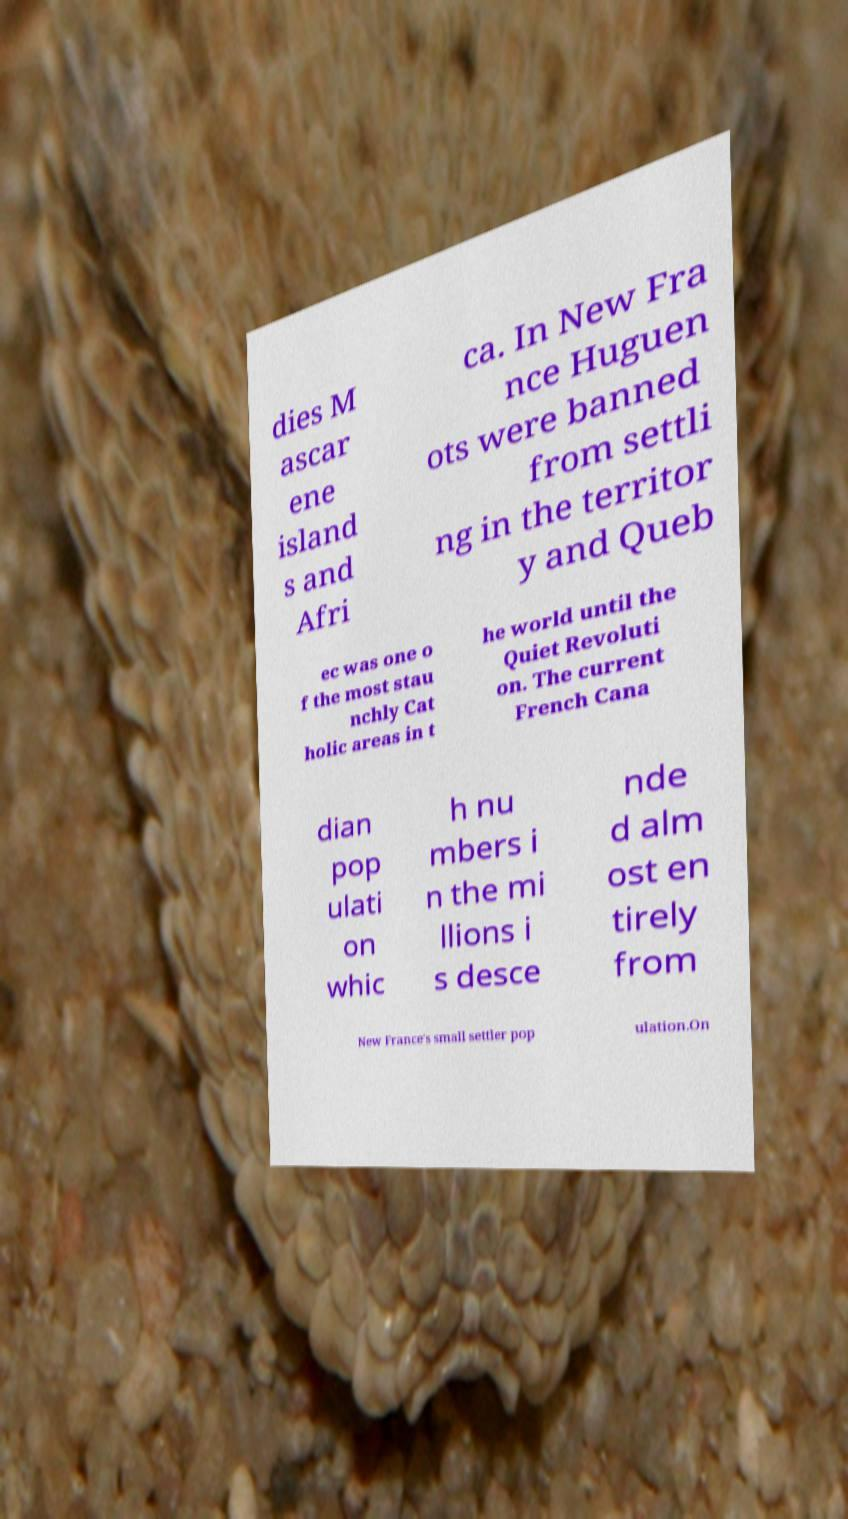Please identify and transcribe the text found in this image. dies M ascar ene island s and Afri ca. In New Fra nce Huguen ots were banned from settli ng in the territor y and Queb ec was one o f the most stau nchly Cat holic areas in t he world until the Quiet Revoluti on. The current French Cana dian pop ulati on whic h nu mbers i n the mi llions i s desce nde d alm ost en tirely from New France's small settler pop ulation.On 